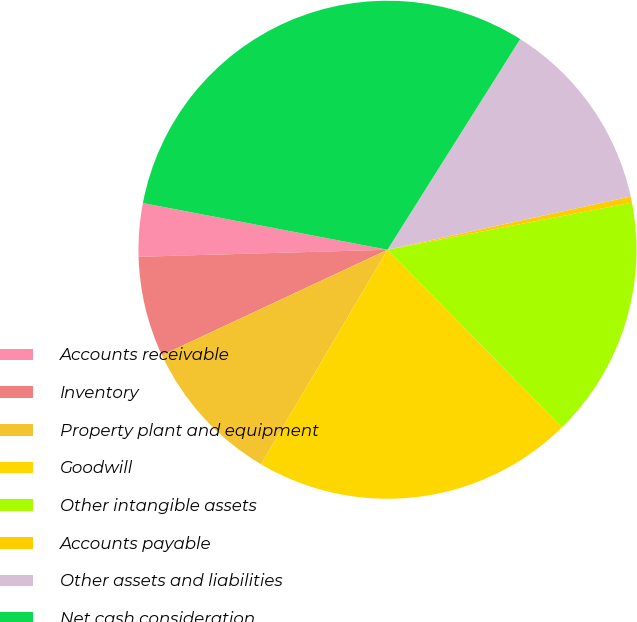<chart> <loc_0><loc_0><loc_500><loc_500><pie_chart><fcel>Accounts receivable<fcel>Inventory<fcel>Property plant and equipment<fcel>Goodwill<fcel>Other intangible assets<fcel>Accounts payable<fcel>Other assets and liabilities<fcel>Net cash consideration<nl><fcel>3.45%<fcel>6.51%<fcel>9.56%<fcel>20.84%<fcel>15.67%<fcel>0.4%<fcel>12.62%<fcel>30.94%<nl></chart> 